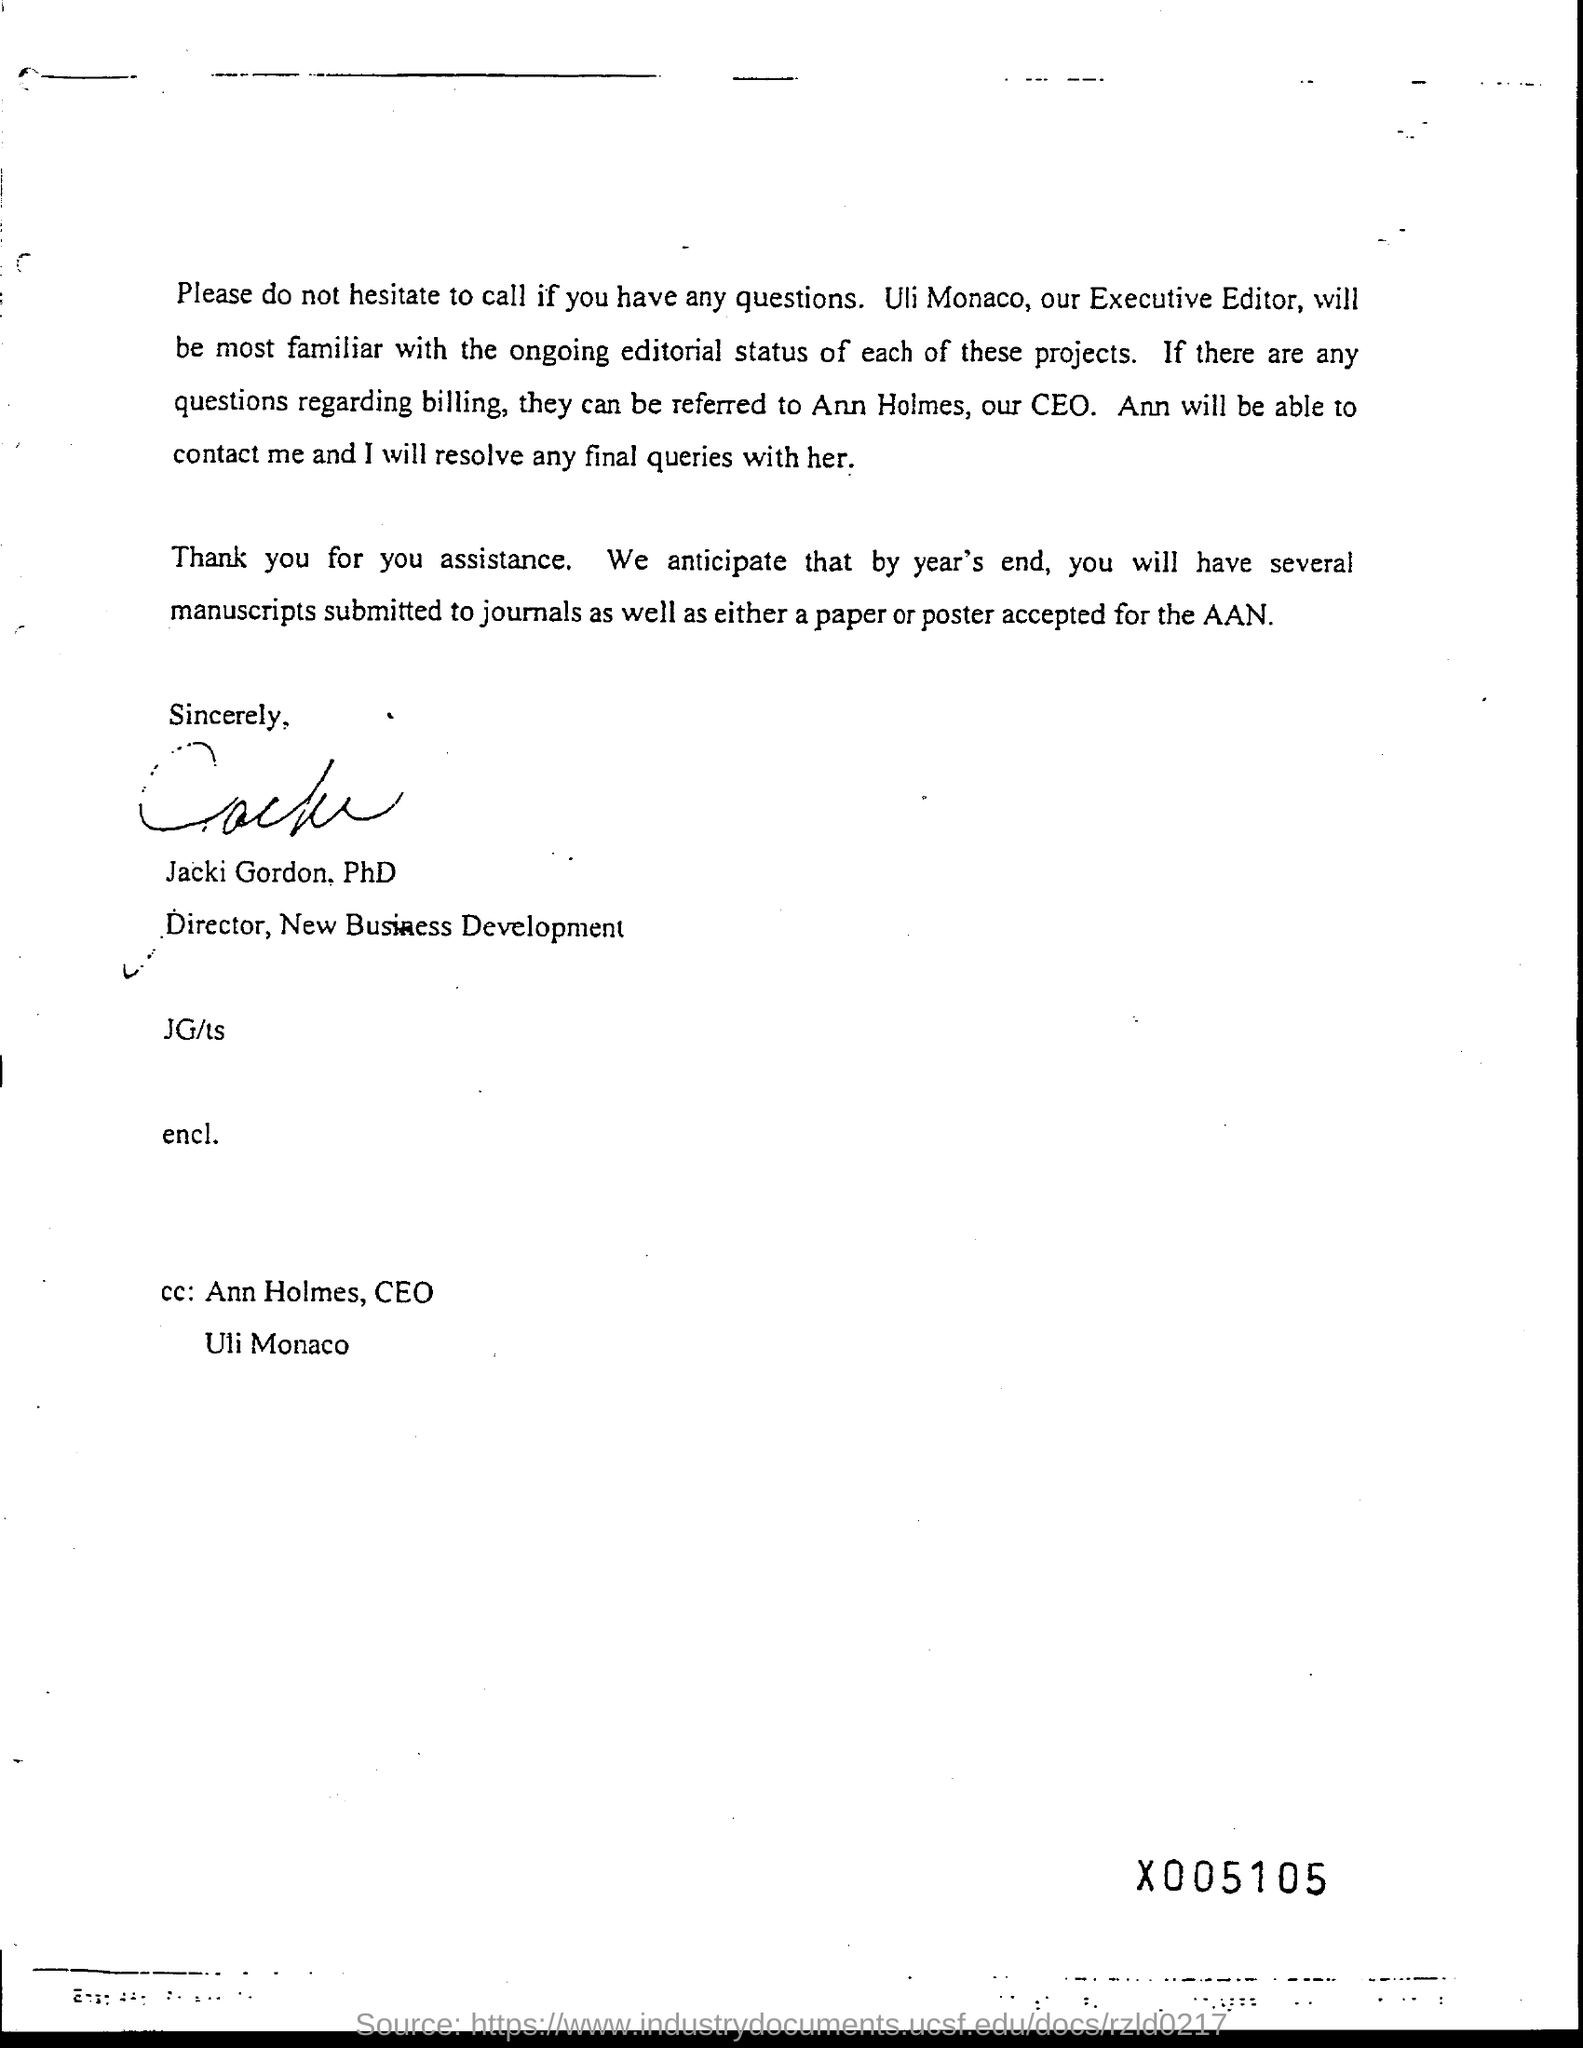Mention a couple of crucial points in this snapshot. Jacki Gordon, PhD, is the Director of New Business Development. Uli Monaco's job title is Executive Editor. 